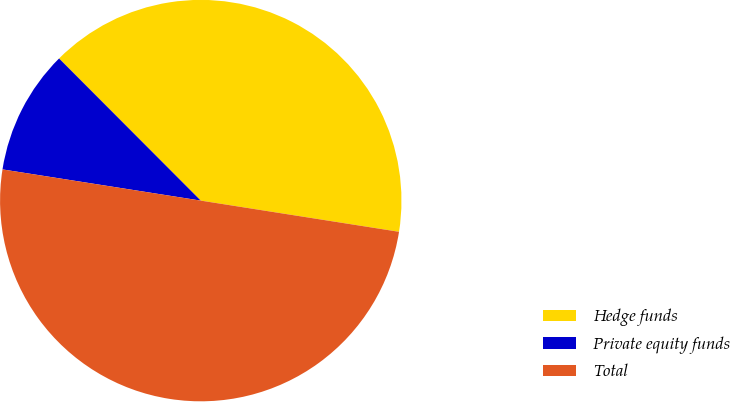Convert chart. <chart><loc_0><loc_0><loc_500><loc_500><pie_chart><fcel>Hedge funds<fcel>Private equity funds<fcel>Total<nl><fcel>39.96%<fcel>10.04%<fcel>50.0%<nl></chart> 